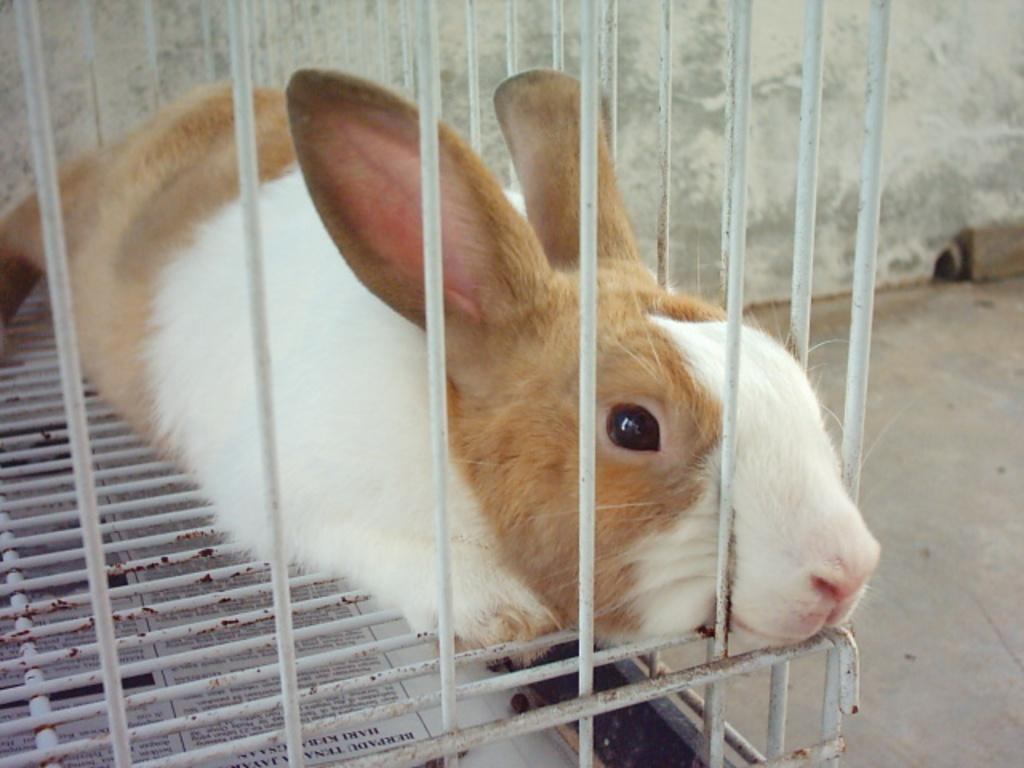What animal can be seen in the image? There is a rabbit in the image. Where is the rabbit sitting? The rabbit is sitting on a cage. What is visible at the bottom of the image? There is newspaper visible at the bottom of the image. What can be seen in the top right corner of the image? There is a wall in the top right corner of the image. What feature is present on the wall? There is a hole in the wall. How many cows are visible in the image? There are no cows present in the image; it features a rabbit sitting on a cage. What type of power source is used to light up the hole in the wall? There is no indication of a power source or lighting in the image; it only shows a hole in the wall. 